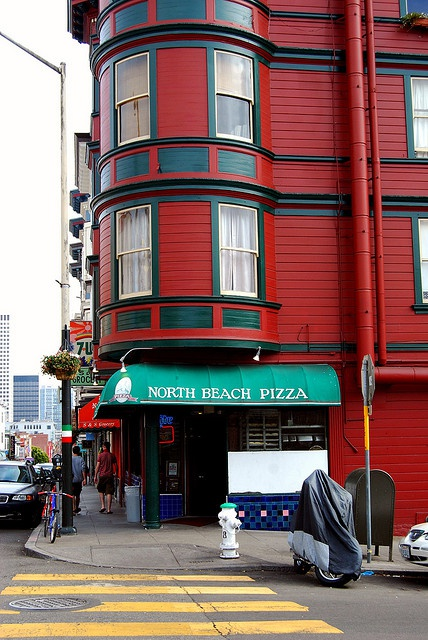Describe the objects in this image and their specific colors. I can see motorcycle in white, black, darkgray, and gray tones, car in white, black, darkgray, and gray tones, people in white, black, maroon, brown, and gray tones, car in white, lightgray, darkgray, black, and gray tones, and bicycle in white, black, gray, darkgray, and maroon tones in this image. 